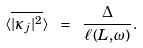<formula> <loc_0><loc_0><loc_500><loc_500>\langle \overline { | \kappa _ { j } | ^ { 2 } } \rangle \ = \ \frac { \Delta } { \ell ( L , \omega ) } .</formula> 